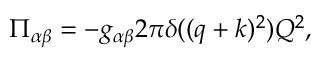<formula> <loc_0><loc_0><loc_500><loc_500>\Pi _ { \alpha \beta } = - g _ { \alpha \beta } 2 \pi \delta ( ( q + k ) ^ { 2 } ) Q ^ { 2 } ,</formula> 